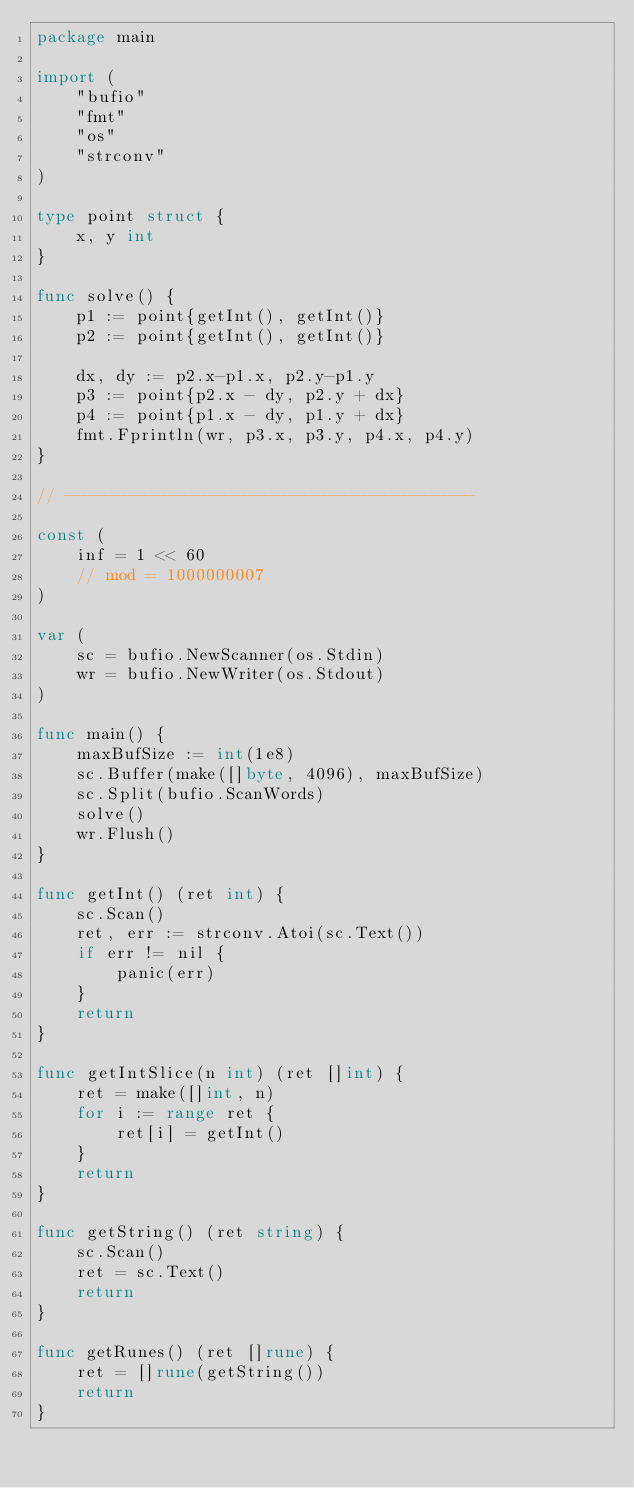Convert code to text. <code><loc_0><loc_0><loc_500><loc_500><_Go_>package main

import (
	"bufio"
	"fmt"
	"os"
	"strconv"
)

type point struct {
	x, y int
}

func solve() {
	p1 := point{getInt(), getInt()}
	p2 := point{getInt(), getInt()}

	dx, dy := p2.x-p1.x, p2.y-p1.y
	p3 := point{p2.x - dy, p2.y + dx}
	p4 := point{p1.x - dy, p1.y + dx}
	fmt.Fprintln(wr, p3.x, p3.y, p4.x, p4.y)
}

// -----------------------------------------

const (
	inf = 1 << 60
	// mod = 1000000007
)

var (
	sc = bufio.NewScanner(os.Stdin)
	wr = bufio.NewWriter(os.Stdout)
)

func main() {
	maxBufSize := int(1e8)
	sc.Buffer(make([]byte, 4096), maxBufSize)
	sc.Split(bufio.ScanWords)
	solve()
	wr.Flush()
}

func getInt() (ret int) {
	sc.Scan()
	ret, err := strconv.Atoi(sc.Text())
	if err != nil {
		panic(err)
	}
	return
}

func getIntSlice(n int) (ret []int) {
	ret = make([]int, n)
	for i := range ret {
		ret[i] = getInt()
	}
	return
}

func getString() (ret string) {
	sc.Scan()
	ret = sc.Text()
	return
}

func getRunes() (ret []rune) {
	ret = []rune(getString())
	return
}
</code> 